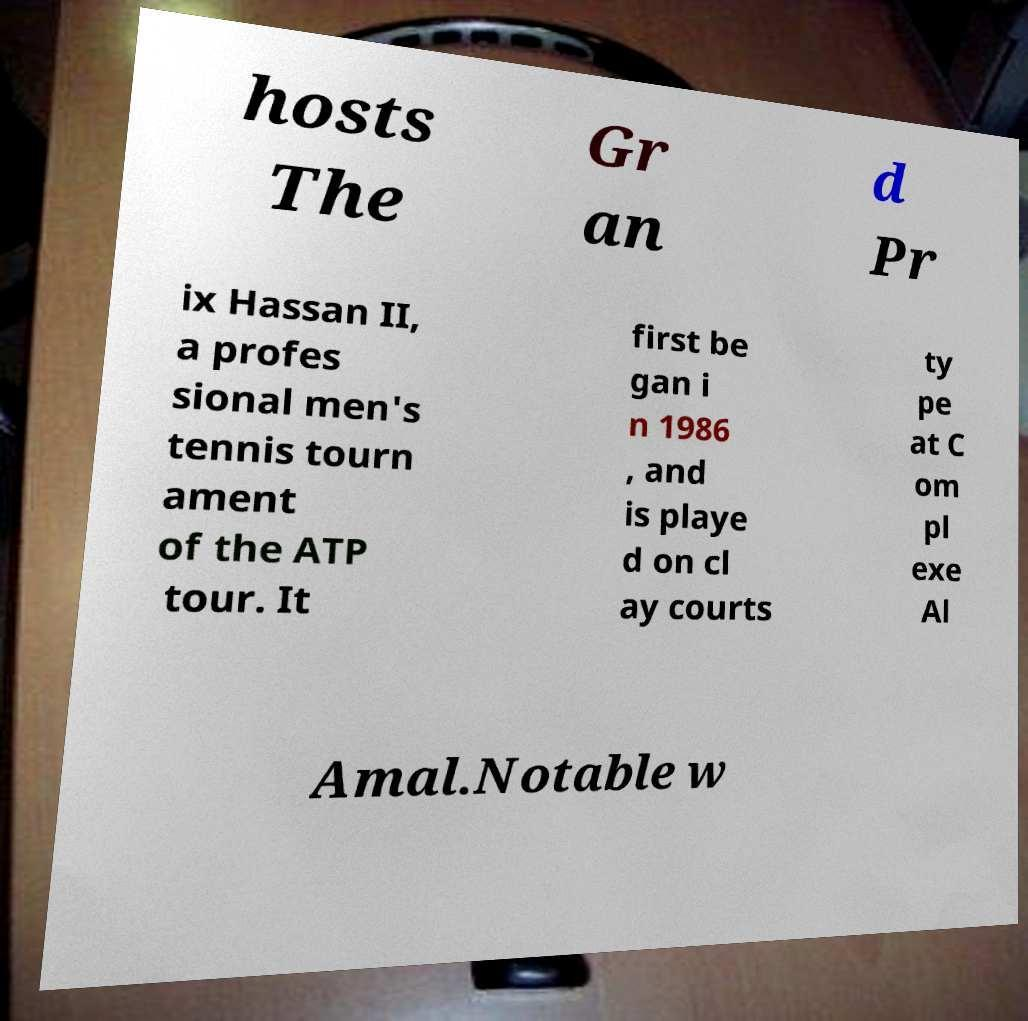There's text embedded in this image that I need extracted. Can you transcribe it verbatim? hosts The Gr an d Pr ix Hassan II, a profes sional men's tennis tourn ament of the ATP tour. It first be gan i n 1986 , and is playe d on cl ay courts ty pe at C om pl exe Al Amal.Notable w 